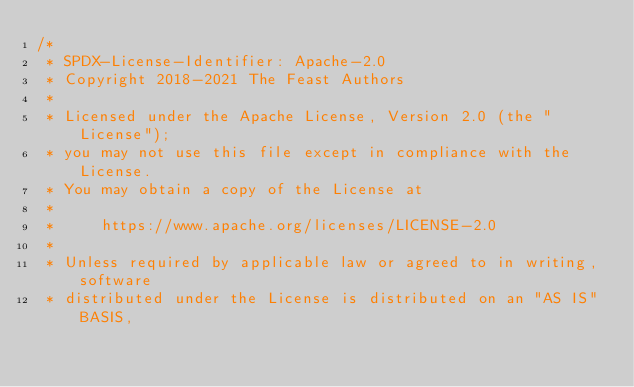<code> <loc_0><loc_0><loc_500><loc_500><_Java_>/*
 * SPDX-License-Identifier: Apache-2.0
 * Copyright 2018-2021 The Feast Authors
 *
 * Licensed under the Apache License, Version 2.0 (the "License");
 * you may not use this file except in compliance with the License.
 * You may obtain a copy of the License at
 *
 *     https://www.apache.org/licenses/LICENSE-2.0
 *
 * Unless required by applicable law or agreed to in writing, software
 * distributed under the License is distributed on an "AS IS" BASIS,</code> 